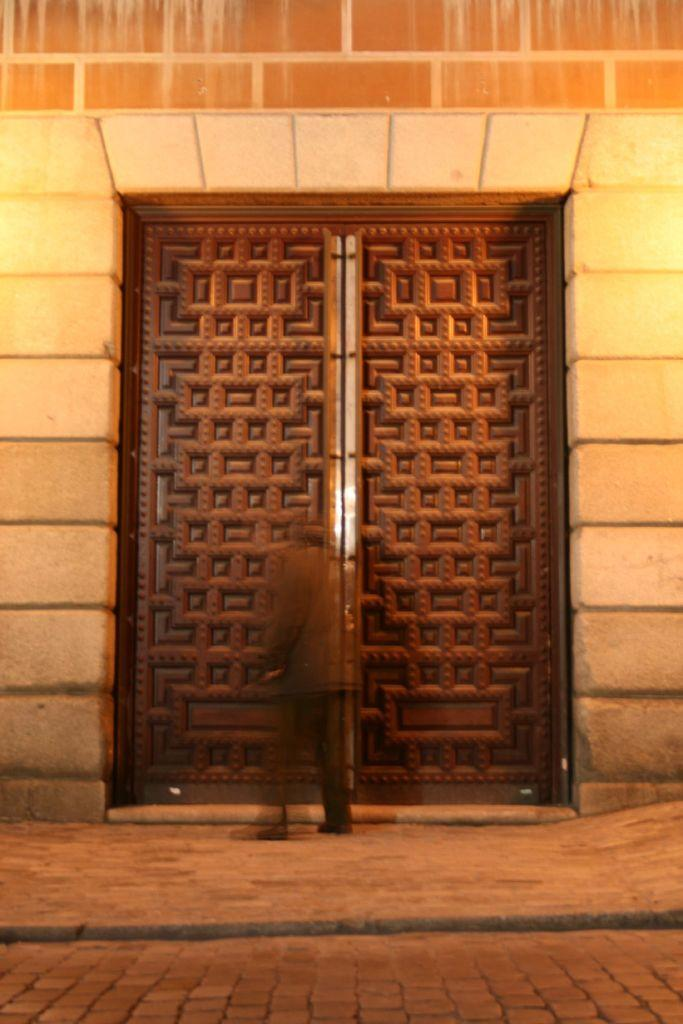Who or what is in the image? There is a person in the image. What is the person doing in the image? The person is standing in front of a building. Can you describe the building in the image? The building has a closed wooden door. What is the surface behind the person? There is a pavement behind the person. What type of fowl is sitting on the person's shoulder in the image? There is no fowl present on the person's shoulder in the image. 